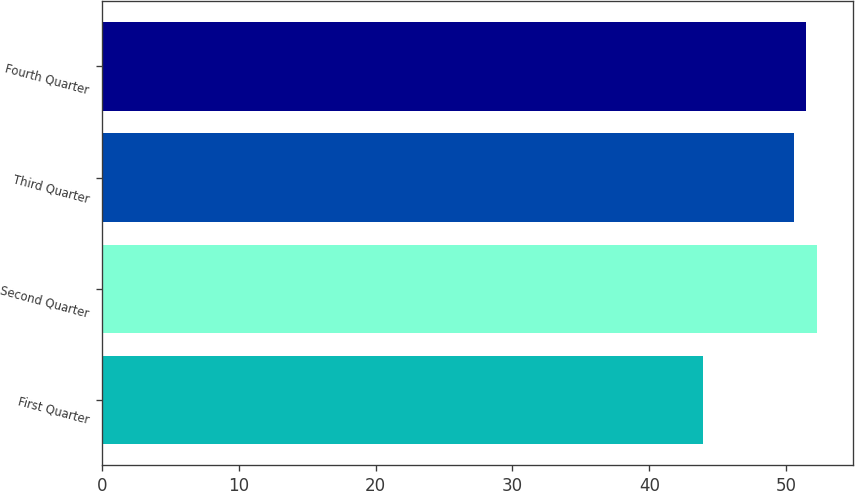Convert chart to OTSL. <chart><loc_0><loc_0><loc_500><loc_500><bar_chart><fcel>First Quarter<fcel>Second Quarter<fcel>Third Quarter<fcel>Fourth Quarter<nl><fcel>43.94<fcel>52.26<fcel>50.56<fcel>51.47<nl></chart> 